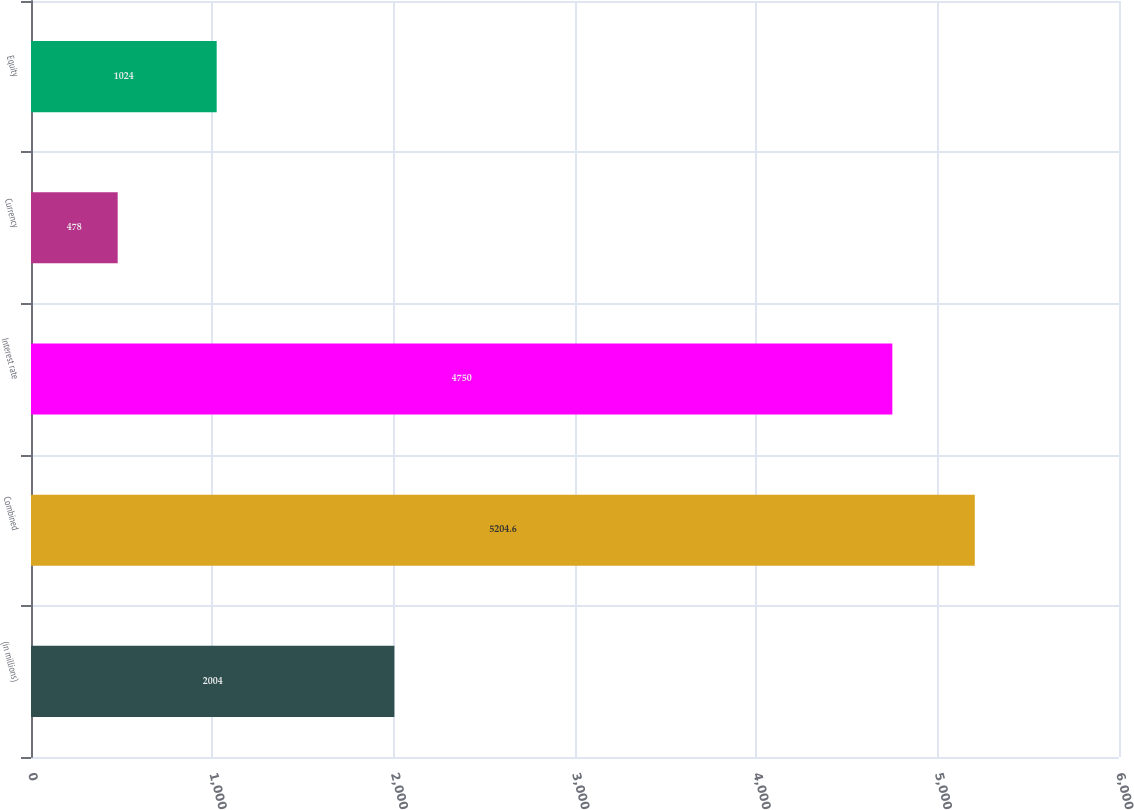Convert chart. <chart><loc_0><loc_0><loc_500><loc_500><bar_chart><fcel>(in millions)<fcel>Combined<fcel>Interest rate<fcel>Currency<fcel>Equity<nl><fcel>2004<fcel>5204.6<fcel>4750<fcel>478<fcel>1024<nl></chart> 